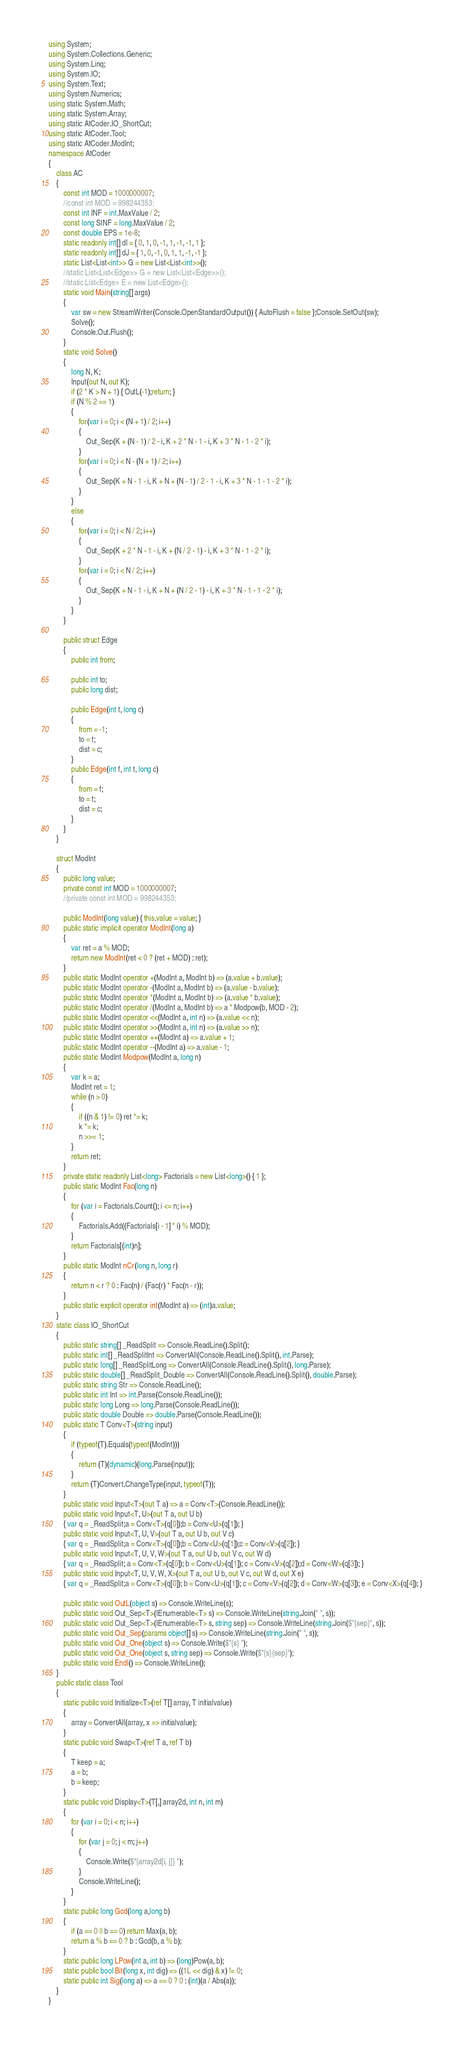<code> <loc_0><loc_0><loc_500><loc_500><_C#_>using System;
using System.Collections.Generic;
using System.Linq;
using System.IO;
using System.Text;
using System.Numerics;
using static System.Math;
using static System.Array;
using static AtCoder.IO_ShortCut;
using static AtCoder.Tool;
using static AtCoder.ModInt;
namespace AtCoder
{
    class AC
    {
        const int MOD = 1000000007;
        //const int MOD = 998244353;
        const int INF = int.MaxValue / 2;
        const long SINF = long.MaxValue / 2;
        const double EPS = 1e-8;
        static readonly int[] dI = { 0, 1, 0, -1, 1, -1, -1, 1 };
        static readonly int[] dJ = { 1, 0, -1, 0, 1, 1, -1, -1 };
        static List<List<int>> G = new List<List<int>>();
        //static List<List<Edge>> G = new List<List<Edge>>();
        //static List<Edge> E = new List<Edge>();
        static void Main(string[] args)
        {
            var sw = new StreamWriter(Console.OpenStandardOutput()) { AutoFlush = false };Console.SetOut(sw);
            Solve();
            Console.Out.Flush();
        }
        static void Solve()
        {
            long N, K;
            Input(out N, out K);
            if (2 * K > N + 1) { OutL(-1);return; }
            if (N % 2 == 1)
            {
                for(var i = 0; i < (N + 1) / 2; i++)
                {
                    Out_Sep(K + (N - 1) / 2 - i, K + 2 * N - 1 - i, K + 3 * N - 1 - 2 * i);
                }
                for(var i = 0; i < N - (N + 1) / 2; i++)
                {
                    Out_Sep(K + N - 1 - i, K + N + (N - 1) / 2 - 1 - i, K + 3 * N - 1 - 1 - 2 * i);
                }
            }
            else
            {
                for(var i = 0; i < N / 2; i++)
                {
                    Out_Sep(K + 2 * N - 1 - i, K + (N / 2 - 1) - i, K + 3 * N - 1 - 2 * i);
                }
                for(var i = 0; i < N / 2; i++)
                {
                    Out_Sep(K + N - 1 - i, K + N + (N / 2 - 1) - i, K + 3 * N - 1 - 1 - 2 * i);
                }
            }
        }
        
        public struct Edge
        {
            public int from;

            public int to;
            public long dist;
            
            public Edge(int t, long c)
            {
                from = -1;
                to = t;
                dist = c;
            }
            public Edge(int f, int t, long c)
            {
                from = f;
                to = t;
                dist = c;
            }
        }
    }
    
    struct ModInt
    {
        public long value;
        private const int MOD = 1000000007;
        //private const int MOD = 998244353;

        public ModInt(long value) { this.value = value; }
        public static implicit operator ModInt(long a)
        {
            var ret = a % MOD;
            return new ModInt(ret < 0 ? (ret + MOD) : ret);
        }
        public static ModInt operator +(ModInt a, ModInt b) => (a.value + b.value);
        public static ModInt operator -(ModInt a, ModInt b) => (a.value - b.value);
        public static ModInt operator *(ModInt a, ModInt b) => (a.value * b.value);
        public static ModInt operator /(ModInt a, ModInt b) => a * Modpow(b, MOD - 2);
        public static ModInt operator <<(ModInt a, int n) => (a.value << n);
        public static ModInt operator >>(ModInt a, int n) => (a.value >> n);
        public static ModInt operator ++(ModInt a) => a.value + 1;
        public static ModInt operator --(ModInt a) => a.value - 1;
        public static ModInt Modpow(ModInt a, long n)
        {
            var k = a;
            ModInt ret = 1;
            while (n > 0)
            {
                if ((n & 1) != 0) ret *= k;
                k *= k;
                n >>= 1;
            }
            return ret;
        }
        private static readonly List<long> Factorials = new List<long>() { 1 };
        public static ModInt Fac(long n)
        {
            for (var i = Factorials.Count(); i <= n; i++)
            {
                Factorials.Add((Factorials[i - 1] * i) % MOD);
            }
            return Factorials[(int)n];
        }
        public static ModInt nCr(long n, long r)
        {
            return n < r ? 0 : Fac(n) / (Fac(r) * Fac(n - r));
        }
        public static explicit operator int(ModInt a) => (int)a.value;
    }
    static class IO_ShortCut
    {
        public static string[] _ReadSplit => Console.ReadLine().Split();
        public static int[] _ReadSplitInt => ConvertAll(Console.ReadLine().Split(), int.Parse);
        public static long[] _ReadSplitLong => ConvertAll(Console.ReadLine().Split(), long.Parse);
        public static double[] _ReadSplit_Double => ConvertAll(Console.ReadLine().Split(), double.Parse);
        public static string Str => Console.ReadLine();
        public static int Int => int.Parse(Console.ReadLine());
        public static long Long => long.Parse(Console.ReadLine());
        public static double Double => double.Parse(Console.ReadLine());
        public static T Conv<T>(string input)
        {
            if (typeof(T).Equals(typeof(ModInt)))
            {
                return (T)(dynamic)(long.Parse(input));
            }
            return (T)Convert.ChangeType(input, typeof(T));
        }
        public static void Input<T>(out T a) => a = Conv<T>(Console.ReadLine());
        public static void Input<T, U>(out T a, out U b)
        { var q = _ReadSplit;a = Conv<T>(q[0]);b = Conv<U>(q[1]); }
        public static void Input<T, U, V>(out T a, out U b, out V c)
        { var q = _ReadSplit;a = Conv<T>(q[0]);b = Conv<U>(q[1]);c = Conv<V>(q[2]); }
        public static void Input<T, U, V, W>(out T a, out U b, out V c, out W d)
        { var q = _ReadSplit; a = Conv<T>(q[0]); b = Conv<U>(q[1]); c = Conv<V>(q[2]);d = Conv<W>(q[3]); }
        public static void Input<T, U, V, W, X>(out T a, out U b, out V c, out W d, out X e)
        { var q = _ReadSplit;a = Conv<T>(q[0]); b = Conv<U>(q[1]); c = Conv<V>(q[2]); d = Conv<W>(q[3]); e = Conv<X>(q[4]); }

        public static void OutL(object s) => Console.WriteLine(s);
        public static void Out_Sep<T>(IEnumerable<T> s) => Console.WriteLine(string.Join(" ", s));
        public static void Out_Sep<T>(IEnumerable<T> s, string sep) => Console.WriteLine(string.Join($"{sep}", s));
        public static void Out_Sep(params object[] s) => Console.WriteLine(string.Join(" ", s));
        public static void Out_One(object s) => Console.Write($"{s} ");
        public static void Out_One(object s, string sep) => Console.Write($"{s}{sep}");
        public static void Endl() => Console.WriteLine();
    }
    public static class Tool
    {
        static public void Initialize<T>(ref T[] array, T initialvalue)
        {
            array = ConvertAll(array, x => initialvalue);
        }
        static public void Swap<T>(ref T a, ref T b)
        {
            T keep = a;
            a = b;
            b = keep;
        }
        static public void Display<T>(T[,] array2d, int n, int m)
        {
            for (var i = 0; i < n; i++)
            {
                for (var j = 0; j < m; j++)
                {
                    Console.Write($"{array2d[i, j]} ");
                }
                Console.WriteLine();
            }
        }
        static public long Gcd(long a,long b)
        {
            if (a == 0 || b == 0) return Max(a, b);
            return a % b == 0 ? b : Gcd(b, a % b);
        }
        static public long LPow(int a, int b) => (long)Pow(a, b);
        static public bool Bit(long x, int dig) => ((1L << dig) & x) != 0;
        static public int Sig(long a) => a == 0 ? 0 : (int)(a / Abs(a));
    }
}</code> 